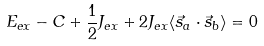<formula> <loc_0><loc_0><loc_500><loc_500>E _ { e x } - C + { \frac { 1 } { 2 } } J _ { e x } + 2 J _ { e x } \langle { \vec { s } } _ { a } \cdot { \vec { s } } _ { b } \rangle = 0</formula> 